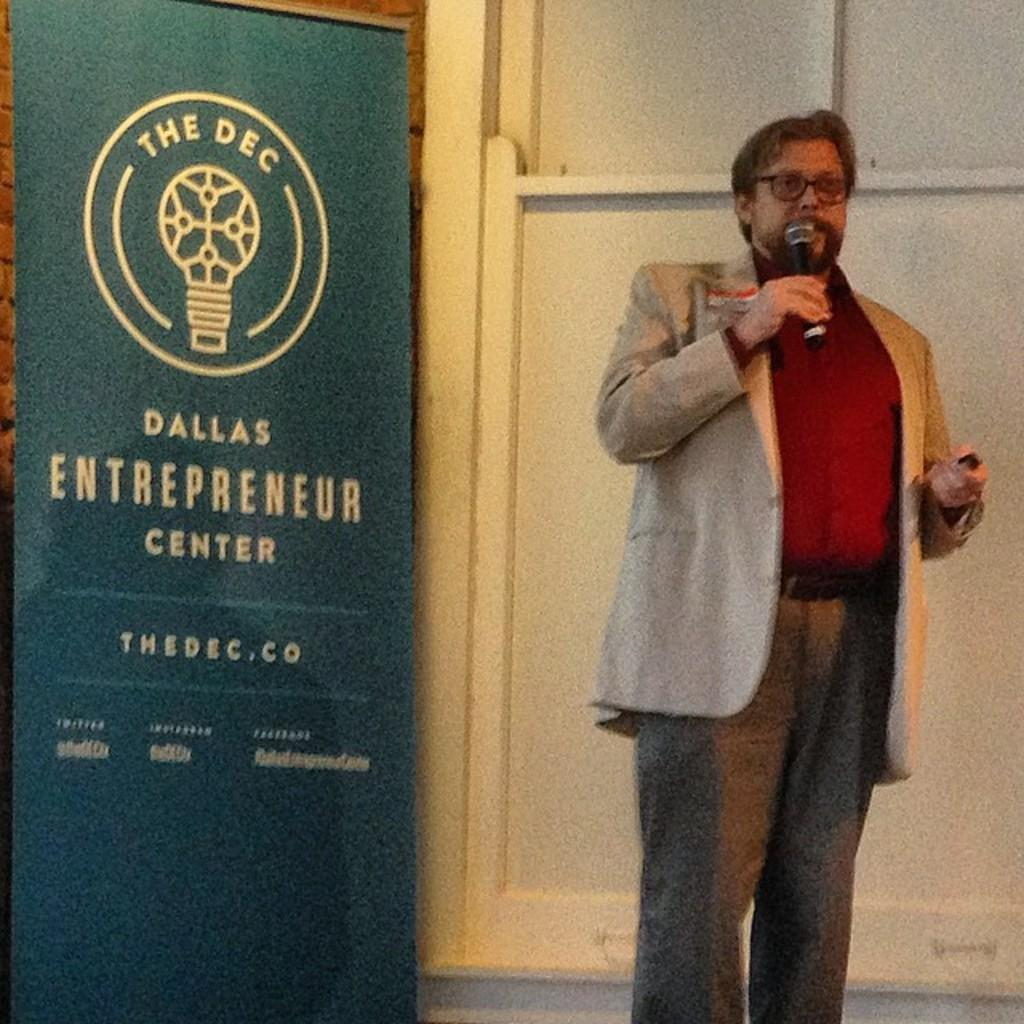<image>
Provide a brief description of the given image. A man gives a speech at the Dallas Entrepreneur Center. 